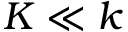Convert formula to latex. <formula><loc_0><loc_0><loc_500><loc_500>K \ll k</formula> 